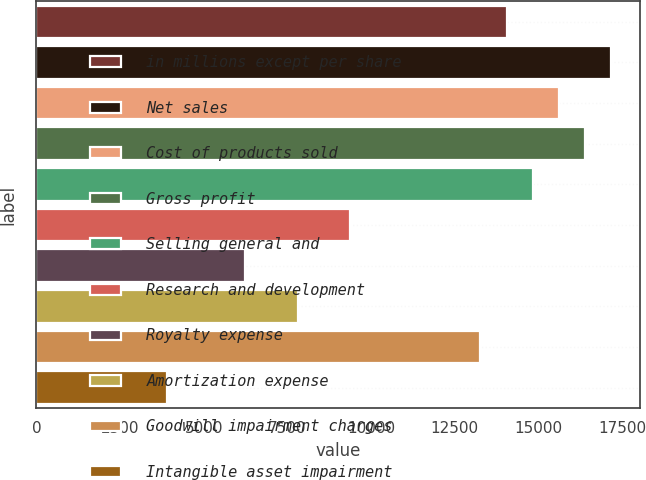Convert chart. <chart><loc_0><loc_0><loc_500><loc_500><bar_chart><fcel>in millions except per share<fcel>Net sales<fcel>Cost of products sold<fcel>Gross profit<fcel>Selling general and<fcel>Research and development<fcel>Royalty expense<fcel>Amortization expense<fcel>Goodwill impairment charges<fcel>Intangible asset impairment<nl><fcel>14050.2<fcel>17172.4<fcel>15611.3<fcel>16391.8<fcel>14830.8<fcel>9367.06<fcel>6244.94<fcel>7806<fcel>13269.7<fcel>3903.35<nl></chart> 